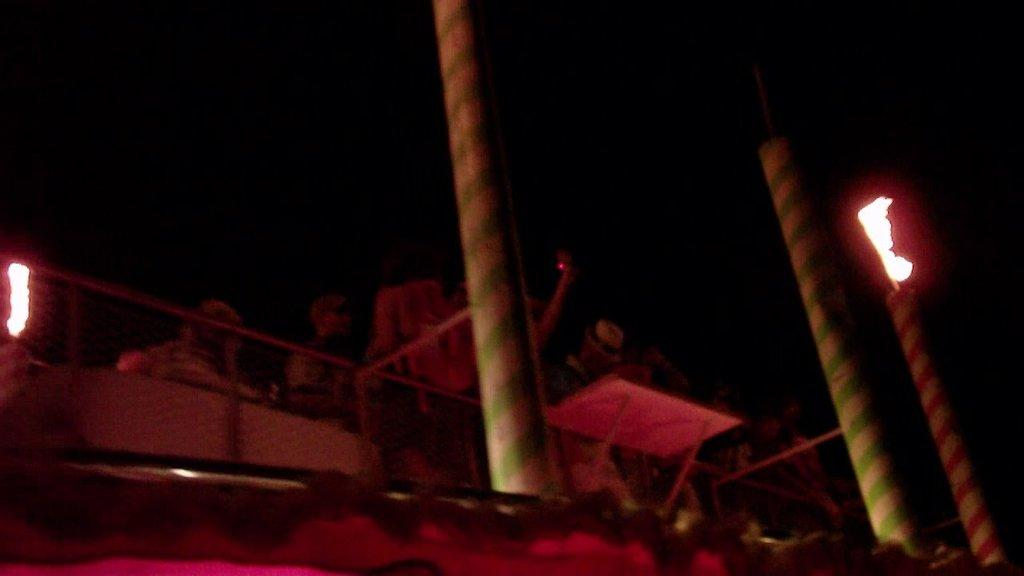What objects can be seen in the image? There are poles, fire, and fencing in the image. What else can be seen in the image? There are people in the image, some of whom are wearing caps. What is the condition of the background in the image? The background of the image is dark. What song can be heard playing in the background of the image? There is no song playing in the background of the image, as it is a still image and not a video or audio recording. 